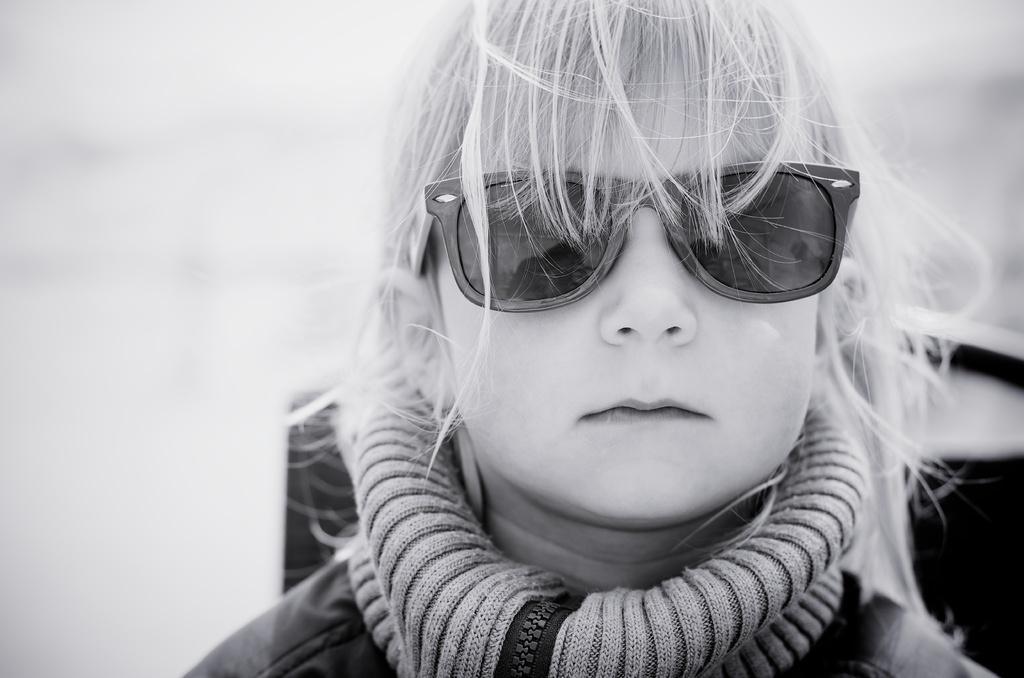Could you give a brief overview of what you see in this image? In this picture there is a small girl on the right side of the image. 